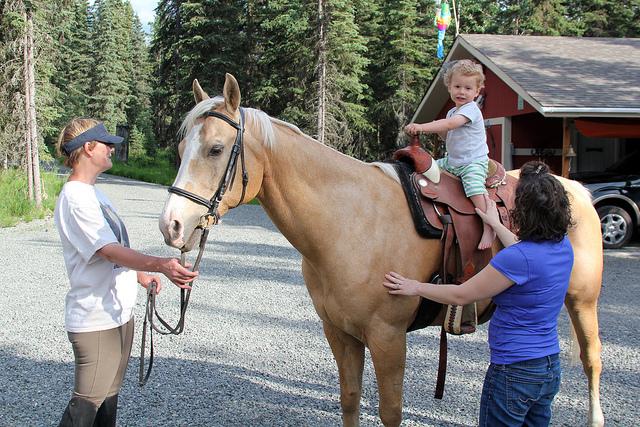Are they standing on grass?
Short answer required. No. Is the person riding the horse a grown up?
Answer briefly. No. How many people are on top of the horse?
Be succinct. 1. 